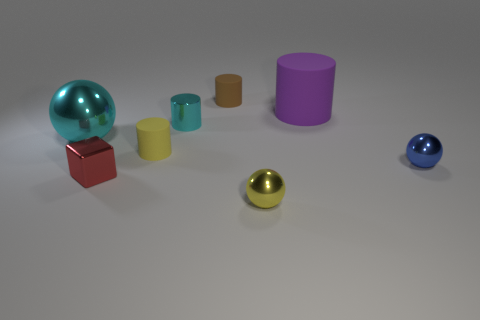Add 1 small rubber cylinders. How many objects exist? 9 Subtract all cubes. How many objects are left? 7 Add 1 red matte cylinders. How many red matte cylinders exist? 1 Subtract all blue balls. How many balls are left? 2 Subtract all cyan shiny cylinders. How many cylinders are left? 3 Subtract 0 green spheres. How many objects are left? 8 Subtract 1 cylinders. How many cylinders are left? 3 Subtract all brown spheres. Subtract all cyan cubes. How many spheres are left? 3 Subtract all purple spheres. How many yellow cubes are left? 0 Subtract all large gray spheres. Subtract all blocks. How many objects are left? 7 